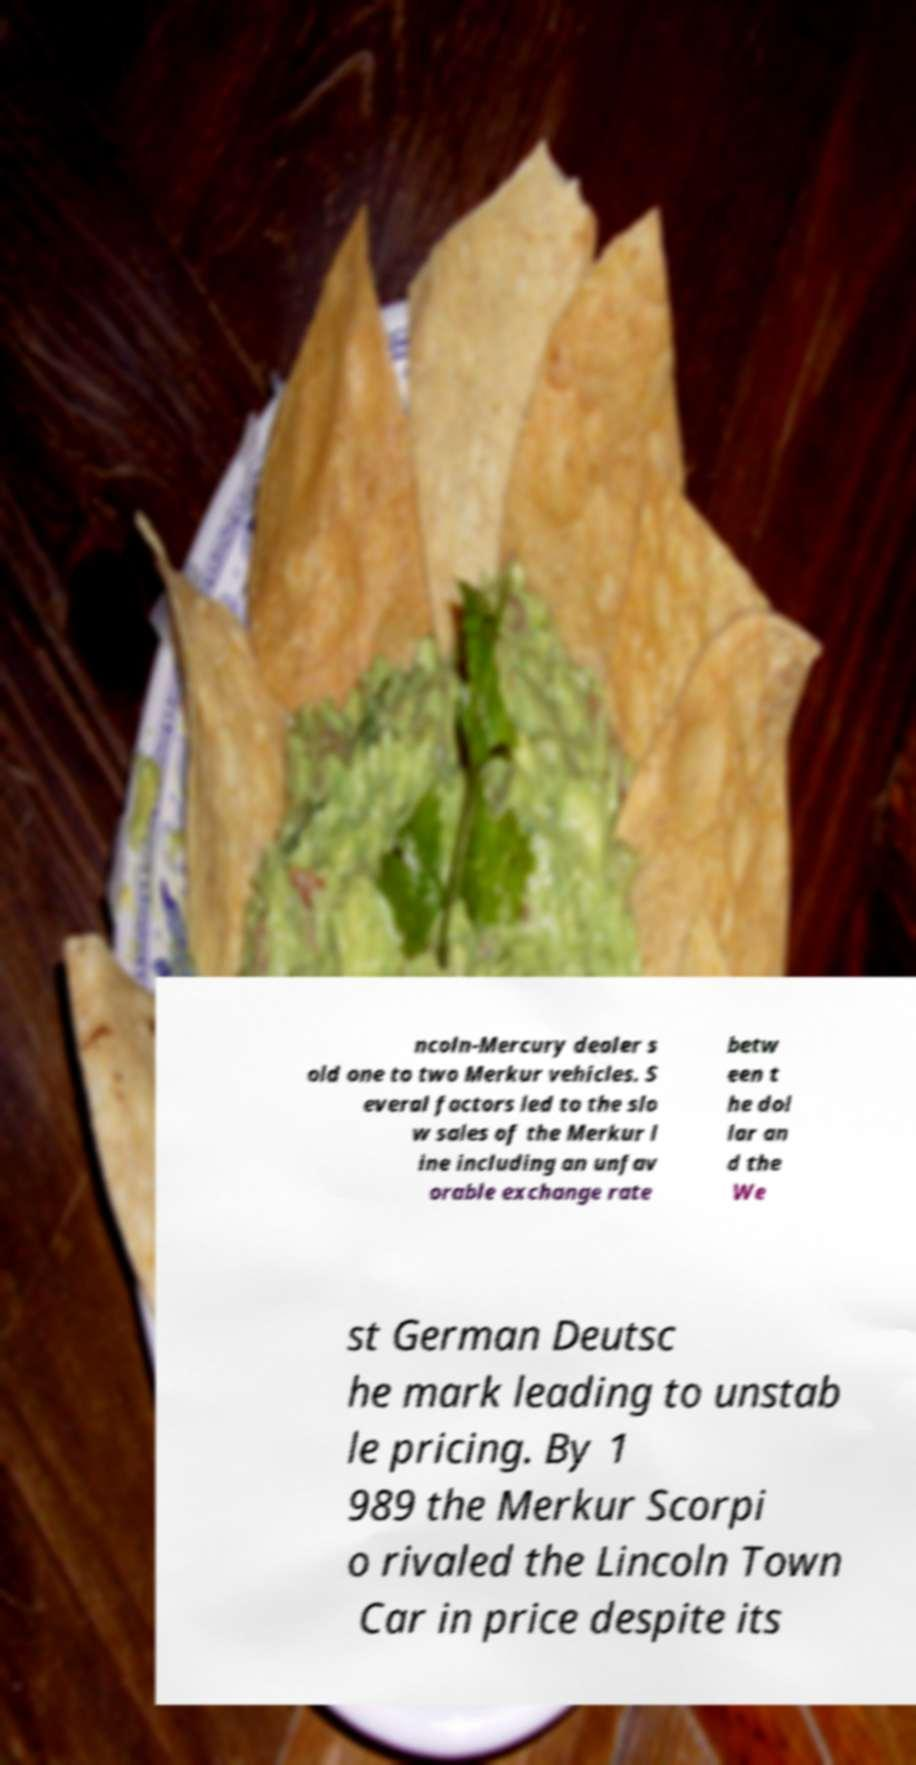There's text embedded in this image that I need extracted. Can you transcribe it verbatim? ncoln-Mercury dealer s old one to two Merkur vehicles. S everal factors led to the slo w sales of the Merkur l ine including an unfav orable exchange rate betw een t he dol lar an d the We st German Deutsc he mark leading to unstab le pricing. By 1 989 the Merkur Scorpi o rivaled the Lincoln Town Car in price despite its 